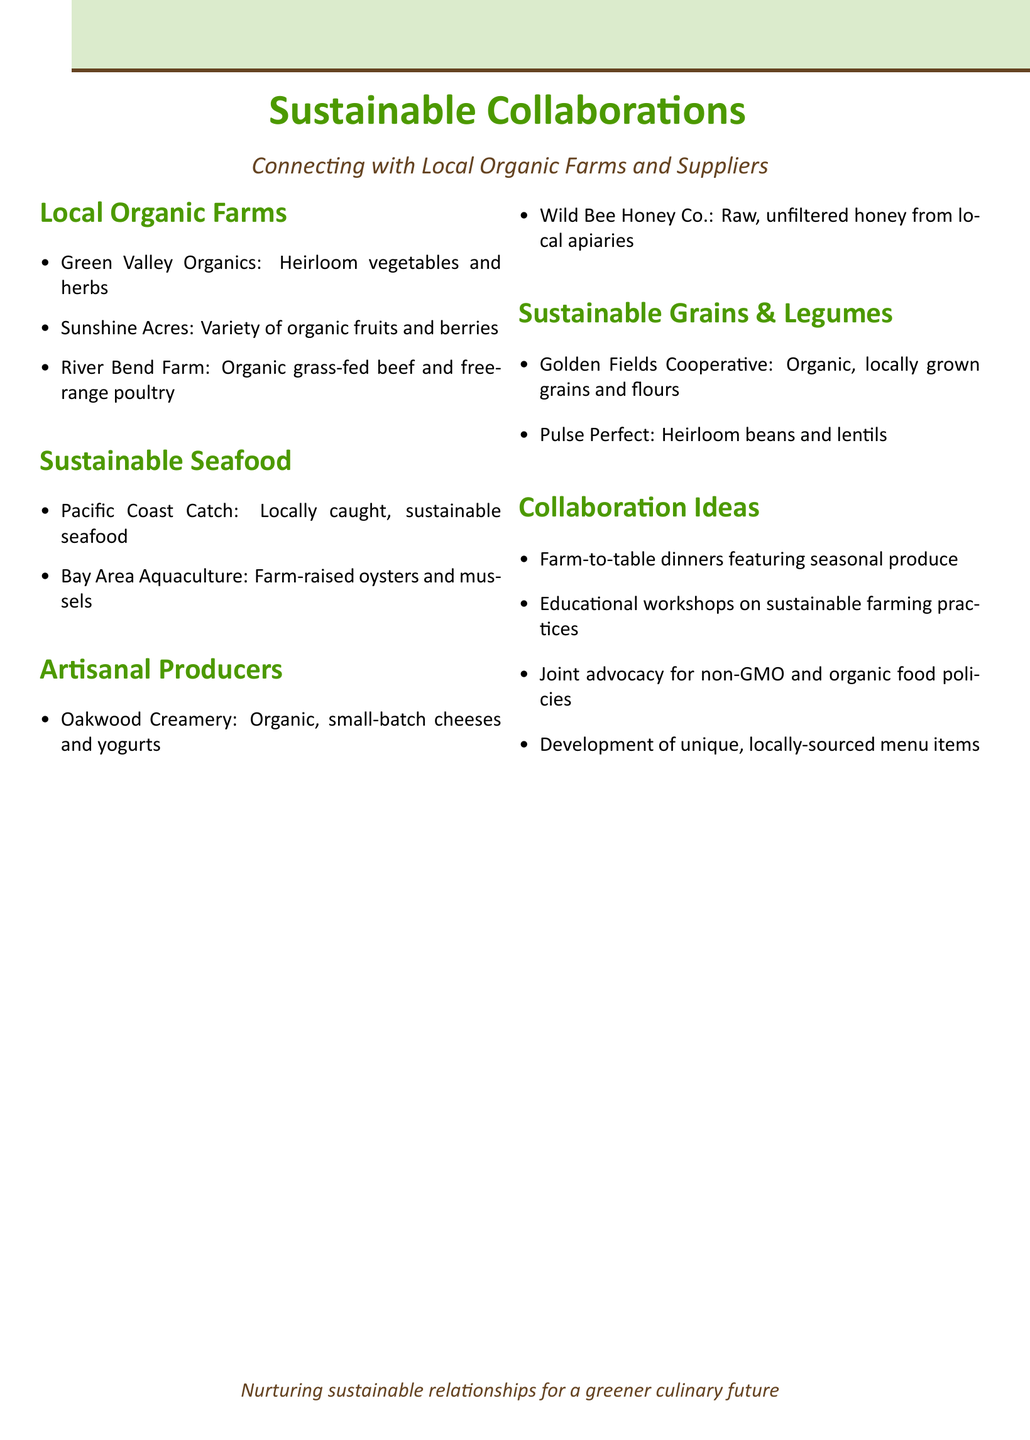What farm specializes in heirloom vegetables? The document lists Green Valley Organics as the farm that specializes in heirloom vegetables and herbs.
Answer: Green Valley Organics Which seafood supplier offers farm-raised oysters? Bay Area Aquaculture is identified as the supplier that offers farm-raised oysters and mussels.
Answer: Bay Area Aquaculture What type of honey does Wild Bee Honey Co. supply? The document states that Wild Bee Honey Co. supplies raw, unfiltered honey from local apiaries.
Answer: Raw, unfiltered honey How many potential collaboration ideas are listed? The document provides a list of four potential collaboration ideas under the specified section.
Answer: Four What is one of the joint advocacy topics suggested? The document mentions joint advocacy for non-GMO and organic food policies as one of the collaboration ideas.
Answer: Non-GMO and organic food policies Which local farm is known for organic grass-fed beef? River Bend Farm is noted for being known for organic, grass-fed beef and free-range poultry.
Answer: River Bend Farm 